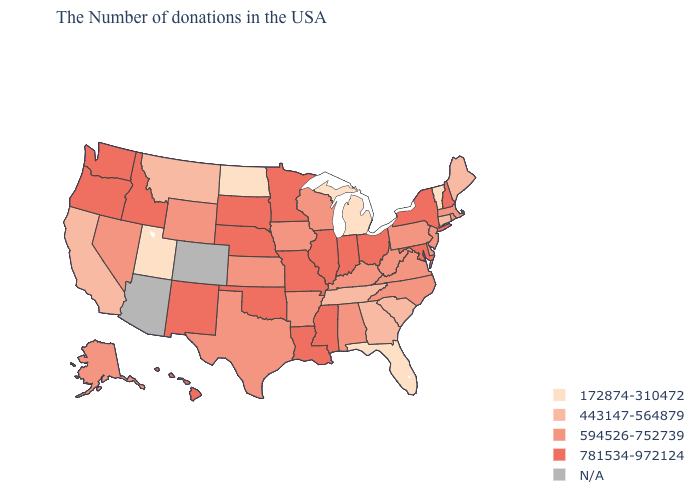Does South Dakota have the lowest value in the USA?
Quick response, please. No. What is the value of Mississippi?
Quick response, please. 781534-972124. Which states have the highest value in the USA?
Short answer required. New Hampshire, New York, Maryland, Ohio, Indiana, Illinois, Mississippi, Louisiana, Missouri, Minnesota, Nebraska, Oklahoma, South Dakota, New Mexico, Idaho, Washington, Oregon, Hawaii. Name the states that have a value in the range 172874-310472?
Answer briefly. Vermont, Florida, Michigan, North Dakota, Utah. Name the states that have a value in the range 594526-752739?
Quick response, please. Massachusetts, Rhode Island, New Jersey, Delaware, Pennsylvania, Virginia, North Carolina, West Virginia, Kentucky, Alabama, Wisconsin, Arkansas, Iowa, Kansas, Texas, Wyoming, Nevada, Alaska. Name the states that have a value in the range 594526-752739?
Write a very short answer. Massachusetts, Rhode Island, New Jersey, Delaware, Pennsylvania, Virginia, North Carolina, West Virginia, Kentucky, Alabama, Wisconsin, Arkansas, Iowa, Kansas, Texas, Wyoming, Nevada, Alaska. What is the value of Ohio?
Quick response, please. 781534-972124. Does the first symbol in the legend represent the smallest category?
Give a very brief answer. Yes. What is the lowest value in the South?
Give a very brief answer. 172874-310472. Name the states that have a value in the range 781534-972124?
Concise answer only. New Hampshire, New York, Maryland, Ohio, Indiana, Illinois, Mississippi, Louisiana, Missouri, Minnesota, Nebraska, Oklahoma, South Dakota, New Mexico, Idaho, Washington, Oregon, Hawaii. Name the states that have a value in the range 443147-564879?
Concise answer only. Maine, Connecticut, South Carolina, Georgia, Tennessee, Montana, California. Name the states that have a value in the range 781534-972124?
Short answer required. New Hampshire, New York, Maryland, Ohio, Indiana, Illinois, Mississippi, Louisiana, Missouri, Minnesota, Nebraska, Oklahoma, South Dakota, New Mexico, Idaho, Washington, Oregon, Hawaii. Name the states that have a value in the range 443147-564879?
Write a very short answer. Maine, Connecticut, South Carolina, Georgia, Tennessee, Montana, California. 